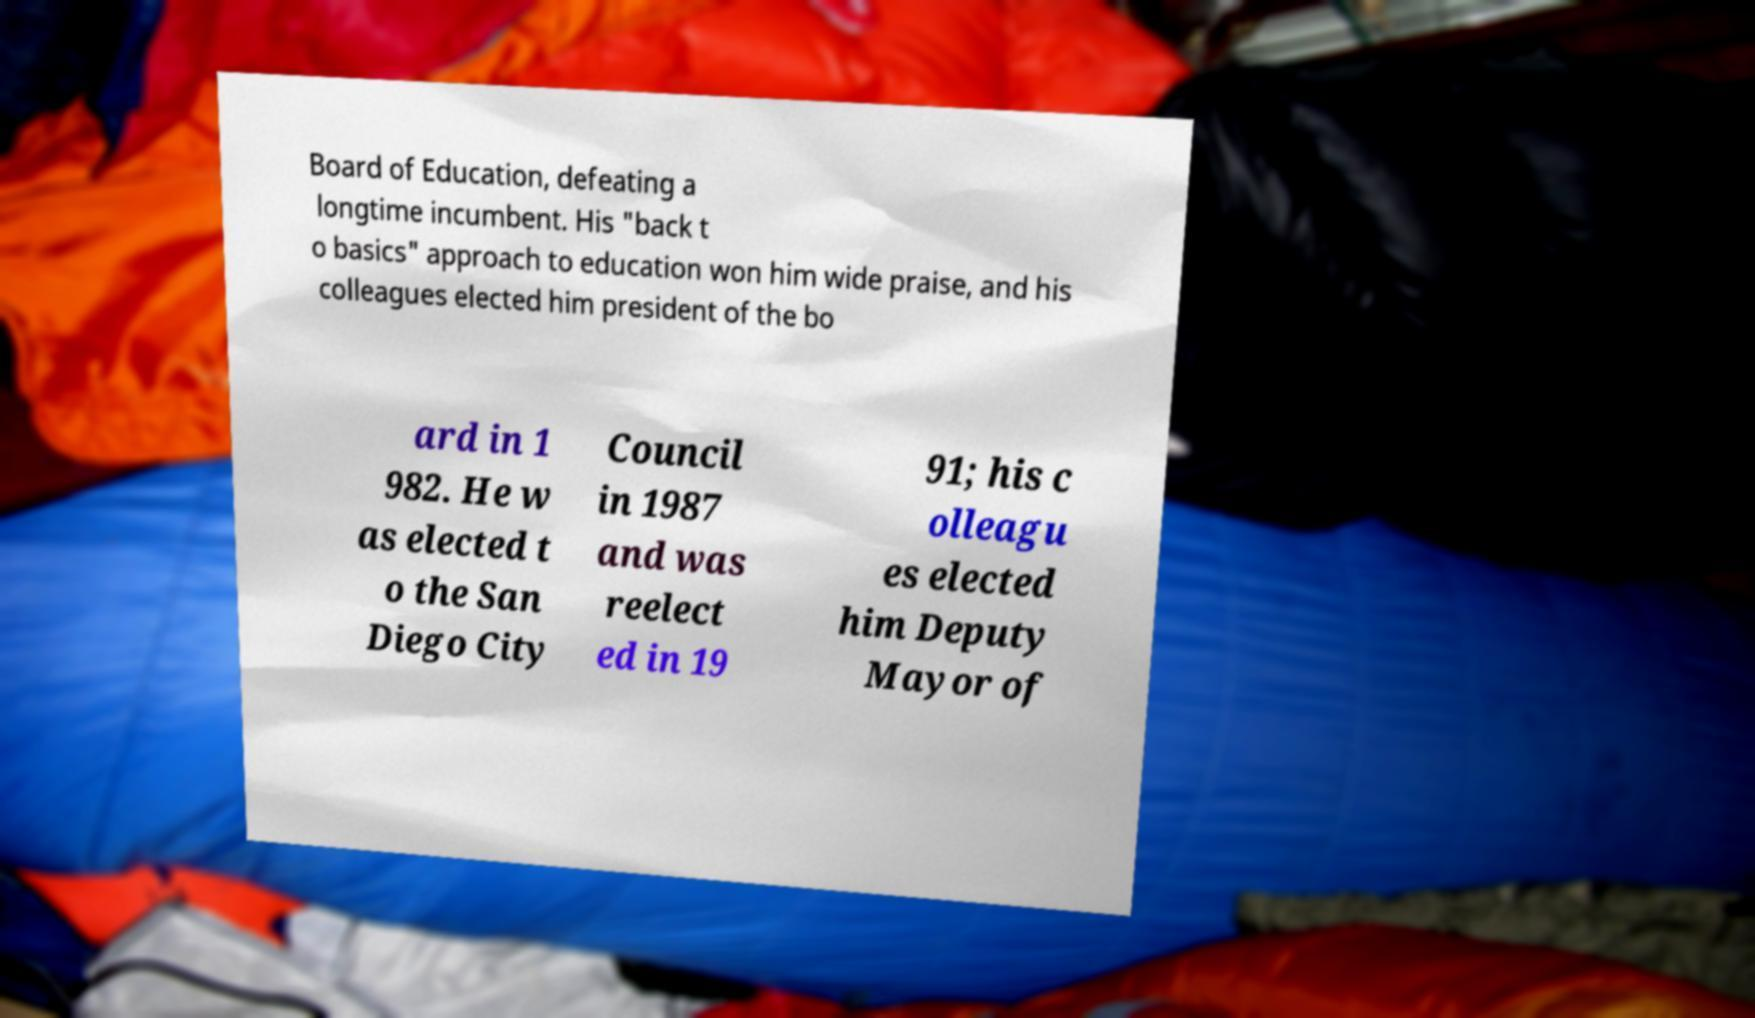I need the written content from this picture converted into text. Can you do that? Board of Education, defeating a longtime incumbent. His "back t o basics" approach to education won him wide praise, and his colleagues elected him president of the bo ard in 1 982. He w as elected t o the San Diego City Council in 1987 and was reelect ed in 19 91; his c olleagu es elected him Deputy Mayor of 